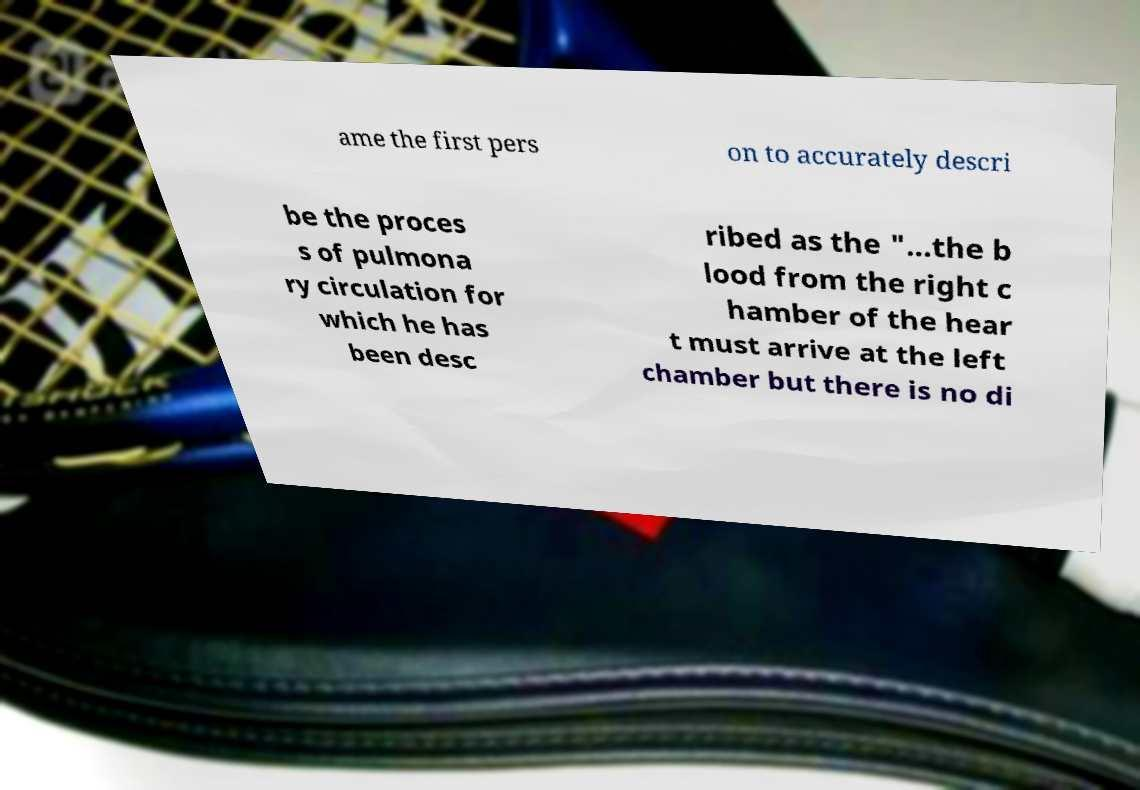There's text embedded in this image that I need extracted. Can you transcribe it verbatim? ame the first pers on to accurately descri be the proces s of pulmona ry circulation for which he has been desc ribed as the "...the b lood from the right c hamber of the hear t must arrive at the left chamber but there is no di 